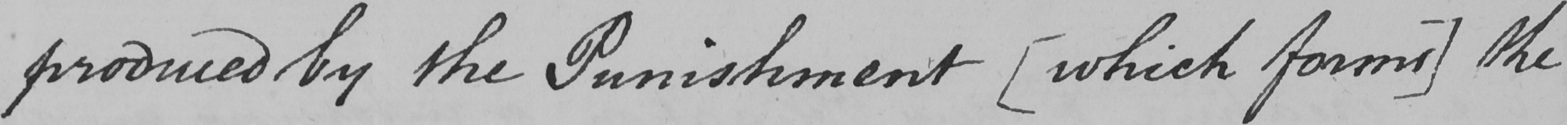Can you read and transcribe this handwriting? produced by the Punishment  [ which forms ]  the 